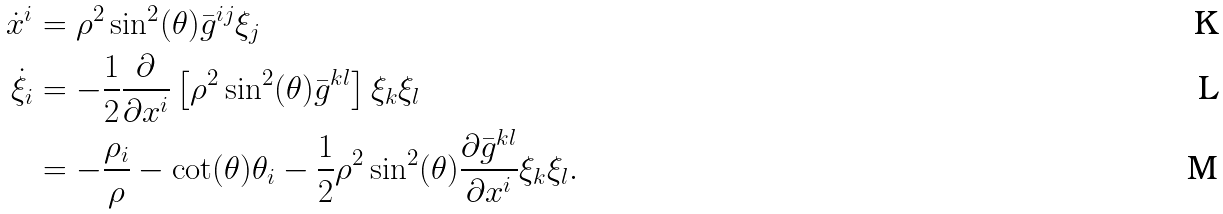Convert formula to latex. <formula><loc_0><loc_0><loc_500><loc_500>\dot { x } ^ { i } & = \rho ^ { 2 } \sin ^ { 2 } ( \theta ) \bar { g } ^ { i j } \xi _ { j } \\ \dot { \xi } _ { i } & = - \frac { 1 } { 2 } \frac { \partial } { \partial x ^ { i } } \left [ \rho ^ { 2 } \sin ^ { 2 } ( \theta ) \bar { g } ^ { k l } \right ] \xi _ { k } \xi _ { l } \\ & = - \frac { \rho _ { i } } { \rho } - \cot ( \theta ) \theta _ { i } - \frac { 1 } { 2 } \rho ^ { 2 } \sin ^ { 2 } ( \theta ) \frac { \partial \bar { g } ^ { k l } } { \partial x ^ { i } } \xi _ { k } \xi _ { l } .</formula> 